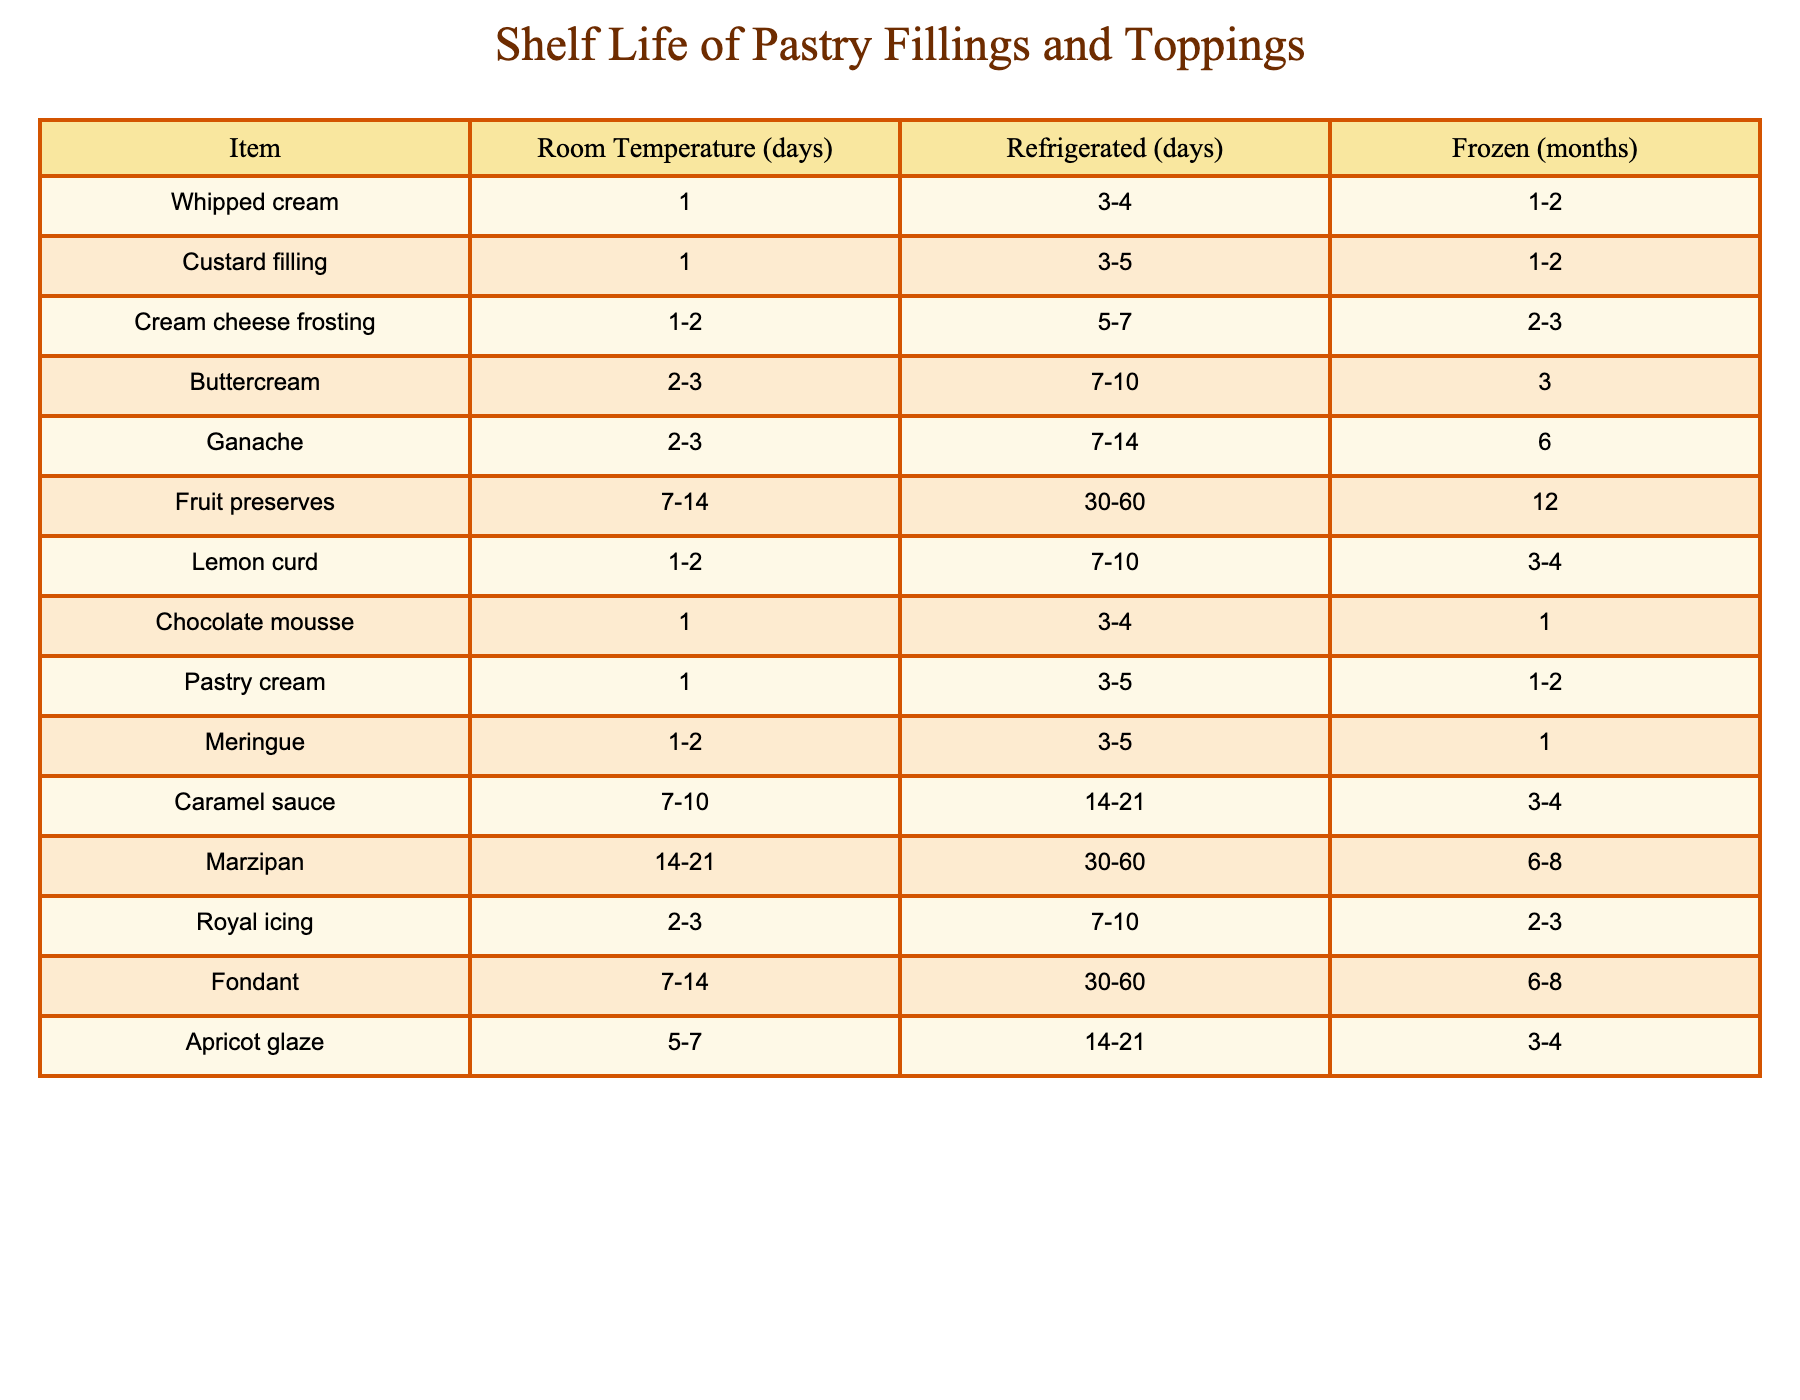What is the shelf life of whipped cream at room temperature? According to the table, whipped cream has a shelf life of 1 day when stored at room temperature.
Answer: 1 day How long can caramel sauce be stored in the refrigerator? The table indicates that caramel sauce can be stored in the refrigerator for 14-21 days.
Answer: 14-21 days Which filling or topping has the longest shelf life when frozen? From the table, fruit preserves have the longest shelf life when frozen, listed as 12 months.
Answer: 12 months Is royal icing safe to consume after being stored room temperature for 4 days? The table shows that royal icing has a shelf life of 2-3 days at room temperature, so consuming it after 4 days is not recommended.
Answer: No If you wanted to freeze both ganache and buttercream, how much longer can ganache last compared to buttercream? Ganache can be frozen for 6 months, while buttercream can be frozen for 3 months. The difference in shelf life when frozen is 6 - 3 = 3 months.
Answer: 3 months What is the average shelf life at room temperature for all the items listed? To find the average, sum the room temperature values: (1 + 1 + 2.5 + 2.5 + 2.5 + 10.5 + 1.5 + 1 + 1 + 1.5 + 7.5 + 14 + 10 + 6 + 5) = 16, and divide by the number of items (15). The average room temperature shelf life is 16/15 = 1.07 days.
Answer: 1.07 days Which items can be stored for more than 3 months when frozen? Referring to the table, the items that can be frozen for more than 3 months are ganache (6 months) and marzipan (6-8 months), and fruit preserves (12 months).
Answer: Ganache, marzipan, fruit preserves How does the refrigerated shelf life of cream cheese frosting compare to that of pastry cream? Cream cheese frosting can be refrigerated for 5-7 days while pastry cream can be refrigerated for 3-5 days. Hence, cream cheese frosting typically lasts longer by 0-2 days.
Answer: Longer by 0-2 days Is it true that lemon curd can last longer at room temperature than chocolate mousse? The table shows lemon curd has a shelf life of 1-2 days at room temperature, while chocolate mousse lasts for only 1 day. So, it is true that lemon curd can last longer.
Answer: Yes 